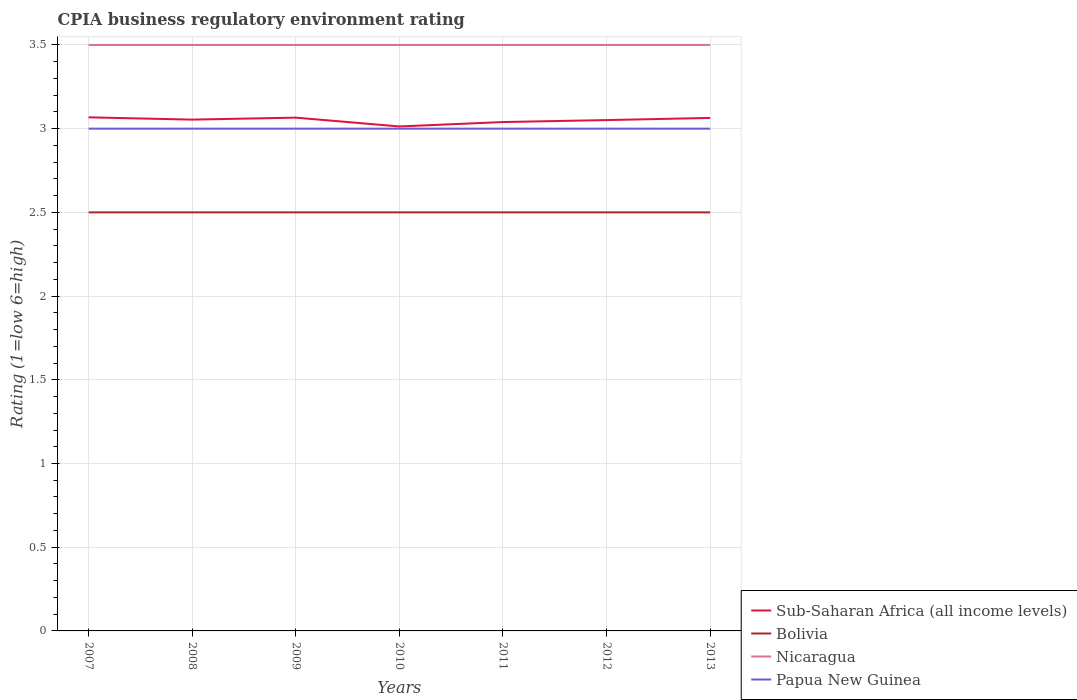Is the number of lines equal to the number of legend labels?
Keep it short and to the point. Yes. Across all years, what is the maximum CPIA rating in Sub-Saharan Africa (all income levels)?
Your answer should be compact. 3.01. In which year was the CPIA rating in Papua New Guinea maximum?
Offer a very short reply. 2007. What is the total CPIA rating in Nicaragua in the graph?
Ensure brevity in your answer.  0. Is the CPIA rating in Nicaragua strictly greater than the CPIA rating in Papua New Guinea over the years?
Make the answer very short. No. How many years are there in the graph?
Ensure brevity in your answer.  7. What is the difference between two consecutive major ticks on the Y-axis?
Provide a short and direct response. 0.5. Where does the legend appear in the graph?
Your answer should be very brief. Bottom right. What is the title of the graph?
Provide a short and direct response. CPIA business regulatory environment rating. Does "Mozambique" appear as one of the legend labels in the graph?
Your response must be concise. No. What is the label or title of the Y-axis?
Offer a terse response. Rating (1=low 6=high). What is the Rating (1=low 6=high) of Sub-Saharan Africa (all income levels) in 2007?
Provide a succinct answer. 3.07. What is the Rating (1=low 6=high) in Bolivia in 2007?
Provide a succinct answer. 2.5. What is the Rating (1=low 6=high) of Nicaragua in 2007?
Your response must be concise. 3.5. What is the Rating (1=low 6=high) in Sub-Saharan Africa (all income levels) in 2008?
Keep it short and to the point. 3.05. What is the Rating (1=low 6=high) of Nicaragua in 2008?
Provide a succinct answer. 3.5. What is the Rating (1=low 6=high) in Sub-Saharan Africa (all income levels) in 2009?
Provide a succinct answer. 3.07. What is the Rating (1=low 6=high) of Sub-Saharan Africa (all income levels) in 2010?
Provide a short and direct response. 3.01. What is the Rating (1=low 6=high) in Bolivia in 2010?
Offer a terse response. 2.5. What is the Rating (1=low 6=high) of Sub-Saharan Africa (all income levels) in 2011?
Your answer should be compact. 3.04. What is the Rating (1=low 6=high) of Sub-Saharan Africa (all income levels) in 2012?
Make the answer very short. 3.05. What is the Rating (1=low 6=high) of Bolivia in 2012?
Your answer should be very brief. 2.5. What is the Rating (1=low 6=high) in Sub-Saharan Africa (all income levels) in 2013?
Offer a very short reply. 3.06. What is the Rating (1=low 6=high) in Nicaragua in 2013?
Provide a short and direct response. 3.5. Across all years, what is the maximum Rating (1=low 6=high) of Sub-Saharan Africa (all income levels)?
Offer a terse response. 3.07. Across all years, what is the maximum Rating (1=low 6=high) in Bolivia?
Give a very brief answer. 2.5. Across all years, what is the maximum Rating (1=low 6=high) in Nicaragua?
Your answer should be very brief. 3.5. Across all years, what is the maximum Rating (1=low 6=high) of Papua New Guinea?
Provide a succinct answer. 3. Across all years, what is the minimum Rating (1=low 6=high) of Sub-Saharan Africa (all income levels)?
Ensure brevity in your answer.  3.01. Across all years, what is the minimum Rating (1=low 6=high) in Nicaragua?
Provide a short and direct response. 3.5. What is the total Rating (1=low 6=high) in Sub-Saharan Africa (all income levels) in the graph?
Your response must be concise. 21.36. What is the difference between the Rating (1=low 6=high) in Sub-Saharan Africa (all income levels) in 2007 and that in 2008?
Make the answer very short. 0.01. What is the difference between the Rating (1=low 6=high) of Papua New Guinea in 2007 and that in 2008?
Provide a succinct answer. 0. What is the difference between the Rating (1=low 6=high) in Sub-Saharan Africa (all income levels) in 2007 and that in 2009?
Offer a very short reply. 0. What is the difference between the Rating (1=low 6=high) of Nicaragua in 2007 and that in 2009?
Your answer should be very brief. 0. What is the difference between the Rating (1=low 6=high) in Sub-Saharan Africa (all income levels) in 2007 and that in 2010?
Make the answer very short. 0.05. What is the difference between the Rating (1=low 6=high) in Sub-Saharan Africa (all income levels) in 2007 and that in 2011?
Offer a very short reply. 0.03. What is the difference between the Rating (1=low 6=high) of Bolivia in 2007 and that in 2011?
Give a very brief answer. 0. What is the difference between the Rating (1=low 6=high) of Sub-Saharan Africa (all income levels) in 2007 and that in 2012?
Give a very brief answer. 0.02. What is the difference between the Rating (1=low 6=high) in Papua New Guinea in 2007 and that in 2012?
Offer a terse response. 0. What is the difference between the Rating (1=low 6=high) of Sub-Saharan Africa (all income levels) in 2007 and that in 2013?
Provide a succinct answer. 0. What is the difference between the Rating (1=low 6=high) in Bolivia in 2007 and that in 2013?
Your response must be concise. 0. What is the difference between the Rating (1=low 6=high) of Papua New Guinea in 2007 and that in 2013?
Keep it short and to the point. 0. What is the difference between the Rating (1=low 6=high) of Sub-Saharan Africa (all income levels) in 2008 and that in 2009?
Provide a succinct answer. -0.01. What is the difference between the Rating (1=low 6=high) of Papua New Guinea in 2008 and that in 2009?
Make the answer very short. 0. What is the difference between the Rating (1=low 6=high) in Sub-Saharan Africa (all income levels) in 2008 and that in 2010?
Your response must be concise. 0.04. What is the difference between the Rating (1=low 6=high) in Nicaragua in 2008 and that in 2010?
Your response must be concise. 0. What is the difference between the Rating (1=low 6=high) of Papua New Guinea in 2008 and that in 2010?
Provide a short and direct response. 0. What is the difference between the Rating (1=low 6=high) of Sub-Saharan Africa (all income levels) in 2008 and that in 2011?
Offer a very short reply. 0.01. What is the difference between the Rating (1=low 6=high) in Nicaragua in 2008 and that in 2011?
Offer a very short reply. 0. What is the difference between the Rating (1=low 6=high) of Papua New Guinea in 2008 and that in 2011?
Ensure brevity in your answer.  0. What is the difference between the Rating (1=low 6=high) of Sub-Saharan Africa (all income levels) in 2008 and that in 2012?
Your answer should be very brief. 0. What is the difference between the Rating (1=low 6=high) of Papua New Guinea in 2008 and that in 2012?
Your answer should be very brief. 0. What is the difference between the Rating (1=low 6=high) in Sub-Saharan Africa (all income levels) in 2008 and that in 2013?
Provide a short and direct response. -0.01. What is the difference between the Rating (1=low 6=high) of Nicaragua in 2008 and that in 2013?
Provide a succinct answer. 0. What is the difference between the Rating (1=low 6=high) of Sub-Saharan Africa (all income levels) in 2009 and that in 2010?
Offer a very short reply. 0.05. What is the difference between the Rating (1=low 6=high) of Sub-Saharan Africa (all income levels) in 2009 and that in 2011?
Keep it short and to the point. 0.03. What is the difference between the Rating (1=low 6=high) in Bolivia in 2009 and that in 2011?
Offer a very short reply. 0. What is the difference between the Rating (1=low 6=high) in Nicaragua in 2009 and that in 2011?
Make the answer very short. 0. What is the difference between the Rating (1=low 6=high) in Papua New Guinea in 2009 and that in 2011?
Ensure brevity in your answer.  0. What is the difference between the Rating (1=low 6=high) of Sub-Saharan Africa (all income levels) in 2009 and that in 2012?
Keep it short and to the point. 0.01. What is the difference between the Rating (1=low 6=high) of Bolivia in 2009 and that in 2012?
Your answer should be compact. 0. What is the difference between the Rating (1=low 6=high) of Papua New Guinea in 2009 and that in 2012?
Make the answer very short. 0. What is the difference between the Rating (1=low 6=high) of Sub-Saharan Africa (all income levels) in 2009 and that in 2013?
Provide a succinct answer. 0. What is the difference between the Rating (1=low 6=high) of Bolivia in 2009 and that in 2013?
Your answer should be compact. 0. What is the difference between the Rating (1=low 6=high) of Nicaragua in 2009 and that in 2013?
Make the answer very short. 0. What is the difference between the Rating (1=low 6=high) in Sub-Saharan Africa (all income levels) in 2010 and that in 2011?
Keep it short and to the point. -0.03. What is the difference between the Rating (1=low 6=high) of Bolivia in 2010 and that in 2011?
Your answer should be very brief. 0. What is the difference between the Rating (1=low 6=high) of Sub-Saharan Africa (all income levels) in 2010 and that in 2012?
Keep it short and to the point. -0.04. What is the difference between the Rating (1=low 6=high) of Bolivia in 2010 and that in 2012?
Make the answer very short. 0. What is the difference between the Rating (1=low 6=high) in Sub-Saharan Africa (all income levels) in 2010 and that in 2013?
Offer a very short reply. -0.05. What is the difference between the Rating (1=low 6=high) of Bolivia in 2010 and that in 2013?
Offer a terse response. 0. What is the difference between the Rating (1=low 6=high) in Nicaragua in 2010 and that in 2013?
Offer a terse response. 0. What is the difference between the Rating (1=low 6=high) of Sub-Saharan Africa (all income levels) in 2011 and that in 2012?
Your answer should be very brief. -0.01. What is the difference between the Rating (1=low 6=high) in Bolivia in 2011 and that in 2012?
Ensure brevity in your answer.  0. What is the difference between the Rating (1=low 6=high) of Papua New Guinea in 2011 and that in 2012?
Your answer should be very brief. 0. What is the difference between the Rating (1=low 6=high) of Sub-Saharan Africa (all income levels) in 2011 and that in 2013?
Give a very brief answer. -0.02. What is the difference between the Rating (1=low 6=high) of Bolivia in 2011 and that in 2013?
Keep it short and to the point. 0. What is the difference between the Rating (1=low 6=high) in Sub-Saharan Africa (all income levels) in 2012 and that in 2013?
Your answer should be very brief. -0.01. What is the difference between the Rating (1=low 6=high) in Bolivia in 2012 and that in 2013?
Offer a terse response. 0. What is the difference between the Rating (1=low 6=high) in Sub-Saharan Africa (all income levels) in 2007 and the Rating (1=low 6=high) in Bolivia in 2008?
Your response must be concise. 0.57. What is the difference between the Rating (1=low 6=high) in Sub-Saharan Africa (all income levels) in 2007 and the Rating (1=low 6=high) in Nicaragua in 2008?
Provide a short and direct response. -0.43. What is the difference between the Rating (1=low 6=high) of Sub-Saharan Africa (all income levels) in 2007 and the Rating (1=low 6=high) of Papua New Guinea in 2008?
Provide a short and direct response. 0.07. What is the difference between the Rating (1=low 6=high) in Sub-Saharan Africa (all income levels) in 2007 and the Rating (1=low 6=high) in Bolivia in 2009?
Keep it short and to the point. 0.57. What is the difference between the Rating (1=low 6=high) in Sub-Saharan Africa (all income levels) in 2007 and the Rating (1=low 6=high) in Nicaragua in 2009?
Your answer should be very brief. -0.43. What is the difference between the Rating (1=low 6=high) in Sub-Saharan Africa (all income levels) in 2007 and the Rating (1=low 6=high) in Papua New Guinea in 2009?
Provide a succinct answer. 0.07. What is the difference between the Rating (1=low 6=high) of Nicaragua in 2007 and the Rating (1=low 6=high) of Papua New Guinea in 2009?
Ensure brevity in your answer.  0.5. What is the difference between the Rating (1=low 6=high) in Sub-Saharan Africa (all income levels) in 2007 and the Rating (1=low 6=high) in Bolivia in 2010?
Your response must be concise. 0.57. What is the difference between the Rating (1=low 6=high) in Sub-Saharan Africa (all income levels) in 2007 and the Rating (1=low 6=high) in Nicaragua in 2010?
Keep it short and to the point. -0.43. What is the difference between the Rating (1=low 6=high) of Sub-Saharan Africa (all income levels) in 2007 and the Rating (1=low 6=high) of Papua New Guinea in 2010?
Ensure brevity in your answer.  0.07. What is the difference between the Rating (1=low 6=high) of Bolivia in 2007 and the Rating (1=low 6=high) of Nicaragua in 2010?
Keep it short and to the point. -1. What is the difference between the Rating (1=low 6=high) of Bolivia in 2007 and the Rating (1=low 6=high) of Papua New Guinea in 2010?
Provide a succinct answer. -0.5. What is the difference between the Rating (1=low 6=high) in Sub-Saharan Africa (all income levels) in 2007 and the Rating (1=low 6=high) in Bolivia in 2011?
Offer a terse response. 0.57. What is the difference between the Rating (1=low 6=high) of Sub-Saharan Africa (all income levels) in 2007 and the Rating (1=low 6=high) of Nicaragua in 2011?
Keep it short and to the point. -0.43. What is the difference between the Rating (1=low 6=high) of Sub-Saharan Africa (all income levels) in 2007 and the Rating (1=low 6=high) of Papua New Guinea in 2011?
Provide a short and direct response. 0.07. What is the difference between the Rating (1=low 6=high) in Bolivia in 2007 and the Rating (1=low 6=high) in Nicaragua in 2011?
Provide a succinct answer. -1. What is the difference between the Rating (1=low 6=high) in Nicaragua in 2007 and the Rating (1=low 6=high) in Papua New Guinea in 2011?
Keep it short and to the point. 0.5. What is the difference between the Rating (1=low 6=high) of Sub-Saharan Africa (all income levels) in 2007 and the Rating (1=low 6=high) of Bolivia in 2012?
Make the answer very short. 0.57. What is the difference between the Rating (1=low 6=high) in Sub-Saharan Africa (all income levels) in 2007 and the Rating (1=low 6=high) in Nicaragua in 2012?
Keep it short and to the point. -0.43. What is the difference between the Rating (1=low 6=high) of Sub-Saharan Africa (all income levels) in 2007 and the Rating (1=low 6=high) of Papua New Guinea in 2012?
Provide a short and direct response. 0.07. What is the difference between the Rating (1=low 6=high) in Bolivia in 2007 and the Rating (1=low 6=high) in Papua New Guinea in 2012?
Give a very brief answer. -0.5. What is the difference between the Rating (1=low 6=high) in Nicaragua in 2007 and the Rating (1=low 6=high) in Papua New Guinea in 2012?
Provide a short and direct response. 0.5. What is the difference between the Rating (1=low 6=high) of Sub-Saharan Africa (all income levels) in 2007 and the Rating (1=low 6=high) of Bolivia in 2013?
Your response must be concise. 0.57. What is the difference between the Rating (1=low 6=high) of Sub-Saharan Africa (all income levels) in 2007 and the Rating (1=low 6=high) of Nicaragua in 2013?
Provide a short and direct response. -0.43. What is the difference between the Rating (1=low 6=high) of Sub-Saharan Africa (all income levels) in 2007 and the Rating (1=low 6=high) of Papua New Guinea in 2013?
Give a very brief answer. 0.07. What is the difference between the Rating (1=low 6=high) in Bolivia in 2007 and the Rating (1=low 6=high) in Nicaragua in 2013?
Your answer should be very brief. -1. What is the difference between the Rating (1=low 6=high) in Bolivia in 2007 and the Rating (1=low 6=high) in Papua New Guinea in 2013?
Provide a succinct answer. -0.5. What is the difference between the Rating (1=low 6=high) of Sub-Saharan Africa (all income levels) in 2008 and the Rating (1=low 6=high) of Bolivia in 2009?
Your answer should be compact. 0.55. What is the difference between the Rating (1=low 6=high) in Sub-Saharan Africa (all income levels) in 2008 and the Rating (1=low 6=high) in Nicaragua in 2009?
Ensure brevity in your answer.  -0.45. What is the difference between the Rating (1=low 6=high) of Sub-Saharan Africa (all income levels) in 2008 and the Rating (1=low 6=high) of Papua New Guinea in 2009?
Provide a succinct answer. 0.05. What is the difference between the Rating (1=low 6=high) of Sub-Saharan Africa (all income levels) in 2008 and the Rating (1=low 6=high) of Bolivia in 2010?
Your answer should be very brief. 0.55. What is the difference between the Rating (1=low 6=high) of Sub-Saharan Africa (all income levels) in 2008 and the Rating (1=low 6=high) of Nicaragua in 2010?
Offer a terse response. -0.45. What is the difference between the Rating (1=low 6=high) in Sub-Saharan Africa (all income levels) in 2008 and the Rating (1=low 6=high) in Papua New Guinea in 2010?
Give a very brief answer. 0.05. What is the difference between the Rating (1=low 6=high) of Bolivia in 2008 and the Rating (1=low 6=high) of Nicaragua in 2010?
Offer a very short reply. -1. What is the difference between the Rating (1=low 6=high) in Bolivia in 2008 and the Rating (1=low 6=high) in Papua New Guinea in 2010?
Your response must be concise. -0.5. What is the difference between the Rating (1=low 6=high) in Sub-Saharan Africa (all income levels) in 2008 and the Rating (1=low 6=high) in Bolivia in 2011?
Your response must be concise. 0.55. What is the difference between the Rating (1=low 6=high) in Sub-Saharan Africa (all income levels) in 2008 and the Rating (1=low 6=high) in Nicaragua in 2011?
Offer a very short reply. -0.45. What is the difference between the Rating (1=low 6=high) of Sub-Saharan Africa (all income levels) in 2008 and the Rating (1=low 6=high) of Papua New Guinea in 2011?
Your answer should be compact. 0.05. What is the difference between the Rating (1=low 6=high) in Bolivia in 2008 and the Rating (1=low 6=high) in Nicaragua in 2011?
Give a very brief answer. -1. What is the difference between the Rating (1=low 6=high) in Sub-Saharan Africa (all income levels) in 2008 and the Rating (1=low 6=high) in Bolivia in 2012?
Offer a very short reply. 0.55. What is the difference between the Rating (1=low 6=high) in Sub-Saharan Africa (all income levels) in 2008 and the Rating (1=low 6=high) in Nicaragua in 2012?
Your answer should be compact. -0.45. What is the difference between the Rating (1=low 6=high) of Sub-Saharan Africa (all income levels) in 2008 and the Rating (1=low 6=high) of Papua New Guinea in 2012?
Ensure brevity in your answer.  0.05. What is the difference between the Rating (1=low 6=high) in Nicaragua in 2008 and the Rating (1=low 6=high) in Papua New Guinea in 2012?
Keep it short and to the point. 0.5. What is the difference between the Rating (1=low 6=high) of Sub-Saharan Africa (all income levels) in 2008 and the Rating (1=low 6=high) of Bolivia in 2013?
Provide a succinct answer. 0.55. What is the difference between the Rating (1=low 6=high) in Sub-Saharan Africa (all income levels) in 2008 and the Rating (1=low 6=high) in Nicaragua in 2013?
Provide a short and direct response. -0.45. What is the difference between the Rating (1=low 6=high) in Sub-Saharan Africa (all income levels) in 2008 and the Rating (1=low 6=high) in Papua New Guinea in 2013?
Your response must be concise. 0.05. What is the difference between the Rating (1=low 6=high) in Nicaragua in 2008 and the Rating (1=low 6=high) in Papua New Guinea in 2013?
Provide a succinct answer. 0.5. What is the difference between the Rating (1=low 6=high) of Sub-Saharan Africa (all income levels) in 2009 and the Rating (1=low 6=high) of Bolivia in 2010?
Ensure brevity in your answer.  0.57. What is the difference between the Rating (1=low 6=high) in Sub-Saharan Africa (all income levels) in 2009 and the Rating (1=low 6=high) in Nicaragua in 2010?
Offer a very short reply. -0.43. What is the difference between the Rating (1=low 6=high) in Sub-Saharan Africa (all income levels) in 2009 and the Rating (1=low 6=high) in Papua New Guinea in 2010?
Your answer should be very brief. 0.07. What is the difference between the Rating (1=low 6=high) of Bolivia in 2009 and the Rating (1=low 6=high) of Nicaragua in 2010?
Ensure brevity in your answer.  -1. What is the difference between the Rating (1=low 6=high) in Bolivia in 2009 and the Rating (1=low 6=high) in Papua New Guinea in 2010?
Make the answer very short. -0.5. What is the difference between the Rating (1=low 6=high) of Sub-Saharan Africa (all income levels) in 2009 and the Rating (1=low 6=high) of Bolivia in 2011?
Keep it short and to the point. 0.57. What is the difference between the Rating (1=low 6=high) of Sub-Saharan Africa (all income levels) in 2009 and the Rating (1=low 6=high) of Nicaragua in 2011?
Provide a succinct answer. -0.43. What is the difference between the Rating (1=low 6=high) of Sub-Saharan Africa (all income levels) in 2009 and the Rating (1=low 6=high) of Papua New Guinea in 2011?
Provide a succinct answer. 0.07. What is the difference between the Rating (1=low 6=high) of Bolivia in 2009 and the Rating (1=low 6=high) of Nicaragua in 2011?
Your response must be concise. -1. What is the difference between the Rating (1=low 6=high) in Nicaragua in 2009 and the Rating (1=low 6=high) in Papua New Guinea in 2011?
Your answer should be compact. 0.5. What is the difference between the Rating (1=low 6=high) of Sub-Saharan Africa (all income levels) in 2009 and the Rating (1=low 6=high) of Bolivia in 2012?
Provide a short and direct response. 0.57. What is the difference between the Rating (1=low 6=high) in Sub-Saharan Africa (all income levels) in 2009 and the Rating (1=low 6=high) in Nicaragua in 2012?
Your response must be concise. -0.43. What is the difference between the Rating (1=low 6=high) of Sub-Saharan Africa (all income levels) in 2009 and the Rating (1=low 6=high) of Papua New Guinea in 2012?
Provide a succinct answer. 0.07. What is the difference between the Rating (1=low 6=high) of Sub-Saharan Africa (all income levels) in 2009 and the Rating (1=low 6=high) of Bolivia in 2013?
Your response must be concise. 0.57. What is the difference between the Rating (1=low 6=high) of Sub-Saharan Africa (all income levels) in 2009 and the Rating (1=low 6=high) of Nicaragua in 2013?
Provide a short and direct response. -0.43. What is the difference between the Rating (1=low 6=high) of Sub-Saharan Africa (all income levels) in 2009 and the Rating (1=low 6=high) of Papua New Guinea in 2013?
Your response must be concise. 0.07. What is the difference between the Rating (1=low 6=high) of Bolivia in 2009 and the Rating (1=low 6=high) of Papua New Guinea in 2013?
Keep it short and to the point. -0.5. What is the difference between the Rating (1=low 6=high) in Nicaragua in 2009 and the Rating (1=low 6=high) in Papua New Guinea in 2013?
Give a very brief answer. 0.5. What is the difference between the Rating (1=low 6=high) of Sub-Saharan Africa (all income levels) in 2010 and the Rating (1=low 6=high) of Bolivia in 2011?
Your response must be concise. 0.51. What is the difference between the Rating (1=low 6=high) in Sub-Saharan Africa (all income levels) in 2010 and the Rating (1=low 6=high) in Nicaragua in 2011?
Offer a very short reply. -0.49. What is the difference between the Rating (1=low 6=high) in Sub-Saharan Africa (all income levels) in 2010 and the Rating (1=low 6=high) in Papua New Guinea in 2011?
Provide a short and direct response. 0.01. What is the difference between the Rating (1=low 6=high) in Bolivia in 2010 and the Rating (1=low 6=high) in Nicaragua in 2011?
Keep it short and to the point. -1. What is the difference between the Rating (1=low 6=high) of Sub-Saharan Africa (all income levels) in 2010 and the Rating (1=low 6=high) of Bolivia in 2012?
Keep it short and to the point. 0.51. What is the difference between the Rating (1=low 6=high) in Sub-Saharan Africa (all income levels) in 2010 and the Rating (1=low 6=high) in Nicaragua in 2012?
Offer a terse response. -0.49. What is the difference between the Rating (1=low 6=high) of Sub-Saharan Africa (all income levels) in 2010 and the Rating (1=low 6=high) of Papua New Guinea in 2012?
Provide a succinct answer. 0.01. What is the difference between the Rating (1=low 6=high) in Bolivia in 2010 and the Rating (1=low 6=high) in Nicaragua in 2012?
Make the answer very short. -1. What is the difference between the Rating (1=low 6=high) of Nicaragua in 2010 and the Rating (1=low 6=high) of Papua New Guinea in 2012?
Provide a short and direct response. 0.5. What is the difference between the Rating (1=low 6=high) in Sub-Saharan Africa (all income levels) in 2010 and the Rating (1=low 6=high) in Bolivia in 2013?
Provide a succinct answer. 0.51. What is the difference between the Rating (1=low 6=high) in Sub-Saharan Africa (all income levels) in 2010 and the Rating (1=low 6=high) in Nicaragua in 2013?
Offer a terse response. -0.49. What is the difference between the Rating (1=low 6=high) of Sub-Saharan Africa (all income levels) in 2010 and the Rating (1=low 6=high) of Papua New Guinea in 2013?
Provide a succinct answer. 0.01. What is the difference between the Rating (1=low 6=high) of Bolivia in 2010 and the Rating (1=low 6=high) of Papua New Guinea in 2013?
Provide a succinct answer. -0.5. What is the difference between the Rating (1=low 6=high) of Nicaragua in 2010 and the Rating (1=low 6=high) of Papua New Guinea in 2013?
Your response must be concise. 0.5. What is the difference between the Rating (1=low 6=high) in Sub-Saharan Africa (all income levels) in 2011 and the Rating (1=low 6=high) in Bolivia in 2012?
Make the answer very short. 0.54. What is the difference between the Rating (1=low 6=high) in Sub-Saharan Africa (all income levels) in 2011 and the Rating (1=low 6=high) in Nicaragua in 2012?
Give a very brief answer. -0.46. What is the difference between the Rating (1=low 6=high) of Sub-Saharan Africa (all income levels) in 2011 and the Rating (1=low 6=high) of Papua New Guinea in 2012?
Offer a very short reply. 0.04. What is the difference between the Rating (1=low 6=high) of Bolivia in 2011 and the Rating (1=low 6=high) of Nicaragua in 2012?
Provide a short and direct response. -1. What is the difference between the Rating (1=low 6=high) of Sub-Saharan Africa (all income levels) in 2011 and the Rating (1=low 6=high) of Bolivia in 2013?
Provide a succinct answer. 0.54. What is the difference between the Rating (1=low 6=high) of Sub-Saharan Africa (all income levels) in 2011 and the Rating (1=low 6=high) of Nicaragua in 2013?
Your response must be concise. -0.46. What is the difference between the Rating (1=low 6=high) of Sub-Saharan Africa (all income levels) in 2011 and the Rating (1=low 6=high) of Papua New Guinea in 2013?
Provide a succinct answer. 0.04. What is the difference between the Rating (1=low 6=high) in Bolivia in 2011 and the Rating (1=low 6=high) in Nicaragua in 2013?
Provide a succinct answer. -1. What is the difference between the Rating (1=low 6=high) of Nicaragua in 2011 and the Rating (1=low 6=high) of Papua New Guinea in 2013?
Your answer should be very brief. 0.5. What is the difference between the Rating (1=low 6=high) in Sub-Saharan Africa (all income levels) in 2012 and the Rating (1=low 6=high) in Bolivia in 2013?
Keep it short and to the point. 0.55. What is the difference between the Rating (1=low 6=high) of Sub-Saharan Africa (all income levels) in 2012 and the Rating (1=low 6=high) of Nicaragua in 2013?
Provide a succinct answer. -0.45. What is the difference between the Rating (1=low 6=high) of Sub-Saharan Africa (all income levels) in 2012 and the Rating (1=low 6=high) of Papua New Guinea in 2013?
Provide a succinct answer. 0.05. What is the difference between the Rating (1=low 6=high) in Nicaragua in 2012 and the Rating (1=low 6=high) in Papua New Guinea in 2013?
Keep it short and to the point. 0.5. What is the average Rating (1=low 6=high) of Sub-Saharan Africa (all income levels) per year?
Your answer should be compact. 3.05. What is the average Rating (1=low 6=high) in Bolivia per year?
Provide a short and direct response. 2.5. In the year 2007, what is the difference between the Rating (1=low 6=high) of Sub-Saharan Africa (all income levels) and Rating (1=low 6=high) of Bolivia?
Your answer should be very brief. 0.57. In the year 2007, what is the difference between the Rating (1=low 6=high) of Sub-Saharan Africa (all income levels) and Rating (1=low 6=high) of Nicaragua?
Offer a very short reply. -0.43. In the year 2007, what is the difference between the Rating (1=low 6=high) of Sub-Saharan Africa (all income levels) and Rating (1=low 6=high) of Papua New Guinea?
Make the answer very short. 0.07. In the year 2007, what is the difference between the Rating (1=low 6=high) of Bolivia and Rating (1=low 6=high) of Nicaragua?
Provide a short and direct response. -1. In the year 2008, what is the difference between the Rating (1=low 6=high) of Sub-Saharan Africa (all income levels) and Rating (1=low 6=high) of Bolivia?
Your answer should be compact. 0.55. In the year 2008, what is the difference between the Rating (1=low 6=high) of Sub-Saharan Africa (all income levels) and Rating (1=low 6=high) of Nicaragua?
Provide a short and direct response. -0.45. In the year 2008, what is the difference between the Rating (1=low 6=high) of Sub-Saharan Africa (all income levels) and Rating (1=low 6=high) of Papua New Guinea?
Provide a succinct answer. 0.05. In the year 2008, what is the difference between the Rating (1=low 6=high) of Bolivia and Rating (1=low 6=high) of Nicaragua?
Your response must be concise. -1. In the year 2009, what is the difference between the Rating (1=low 6=high) of Sub-Saharan Africa (all income levels) and Rating (1=low 6=high) of Bolivia?
Provide a short and direct response. 0.57. In the year 2009, what is the difference between the Rating (1=low 6=high) in Sub-Saharan Africa (all income levels) and Rating (1=low 6=high) in Nicaragua?
Make the answer very short. -0.43. In the year 2009, what is the difference between the Rating (1=low 6=high) of Sub-Saharan Africa (all income levels) and Rating (1=low 6=high) of Papua New Guinea?
Give a very brief answer. 0.07. In the year 2009, what is the difference between the Rating (1=low 6=high) of Bolivia and Rating (1=low 6=high) of Nicaragua?
Give a very brief answer. -1. In the year 2009, what is the difference between the Rating (1=low 6=high) in Bolivia and Rating (1=low 6=high) in Papua New Guinea?
Your response must be concise. -0.5. In the year 2009, what is the difference between the Rating (1=low 6=high) of Nicaragua and Rating (1=low 6=high) of Papua New Guinea?
Your response must be concise. 0.5. In the year 2010, what is the difference between the Rating (1=low 6=high) of Sub-Saharan Africa (all income levels) and Rating (1=low 6=high) of Bolivia?
Offer a very short reply. 0.51. In the year 2010, what is the difference between the Rating (1=low 6=high) of Sub-Saharan Africa (all income levels) and Rating (1=low 6=high) of Nicaragua?
Offer a very short reply. -0.49. In the year 2010, what is the difference between the Rating (1=low 6=high) in Sub-Saharan Africa (all income levels) and Rating (1=low 6=high) in Papua New Guinea?
Provide a succinct answer. 0.01. In the year 2010, what is the difference between the Rating (1=low 6=high) in Bolivia and Rating (1=low 6=high) in Nicaragua?
Make the answer very short. -1. In the year 2011, what is the difference between the Rating (1=low 6=high) of Sub-Saharan Africa (all income levels) and Rating (1=low 6=high) of Bolivia?
Offer a terse response. 0.54. In the year 2011, what is the difference between the Rating (1=low 6=high) in Sub-Saharan Africa (all income levels) and Rating (1=low 6=high) in Nicaragua?
Make the answer very short. -0.46. In the year 2011, what is the difference between the Rating (1=low 6=high) in Sub-Saharan Africa (all income levels) and Rating (1=low 6=high) in Papua New Guinea?
Your answer should be compact. 0.04. In the year 2012, what is the difference between the Rating (1=low 6=high) in Sub-Saharan Africa (all income levels) and Rating (1=low 6=high) in Bolivia?
Your response must be concise. 0.55. In the year 2012, what is the difference between the Rating (1=low 6=high) of Sub-Saharan Africa (all income levels) and Rating (1=low 6=high) of Nicaragua?
Give a very brief answer. -0.45. In the year 2012, what is the difference between the Rating (1=low 6=high) in Sub-Saharan Africa (all income levels) and Rating (1=low 6=high) in Papua New Guinea?
Offer a terse response. 0.05. In the year 2012, what is the difference between the Rating (1=low 6=high) of Bolivia and Rating (1=low 6=high) of Nicaragua?
Your answer should be compact. -1. In the year 2012, what is the difference between the Rating (1=low 6=high) of Bolivia and Rating (1=low 6=high) of Papua New Guinea?
Keep it short and to the point. -0.5. In the year 2013, what is the difference between the Rating (1=low 6=high) in Sub-Saharan Africa (all income levels) and Rating (1=low 6=high) in Bolivia?
Keep it short and to the point. 0.56. In the year 2013, what is the difference between the Rating (1=low 6=high) of Sub-Saharan Africa (all income levels) and Rating (1=low 6=high) of Nicaragua?
Provide a succinct answer. -0.44. In the year 2013, what is the difference between the Rating (1=low 6=high) in Sub-Saharan Africa (all income levels) and Rating (1=low 6=high) in Papua New Guinea?
Your answer should be compact. 0.06. In the year 2013, what is the difference between the Rating (1=low 6=high) in Bolivia and Rating (1=low 6=high) in Nicaragua?
Your answer should be very brief. -1. What is the ratio of the Rating (1=low 6=high) in Nicaragua in 2007 to that in 2008?
Your answer should be very brief. 1. What is the ratio of the Rating (1=low 6=high) of Papua New Guinea in 2007 to that in 2008?
Keep it short and to the point. 1. What is the ratio of the Rating (1=low 6=high) of Sub-Saharan Africa (all income levels) in 2007 to that in 2009?
Keep it short and to the point. 1. What is the ratio of the Rating (1=low 6=high) of Nicaragua in 2007 to that in 2009?
Provide a succinct answer. 1. What is the ratio of the Rating (1=low 6=high) in Sub-Saharan Africa (all income levels) in 2007 to that in 2010?
Provide a succinct answer. 1.02. What is the ratio of the Rating (1=low 6=high) of Bolivia in 2007 to that in 2010?
Make the answer very short. 1. What is the ratio of the Rating (1=low 6=high) of Nicaragua in 2007 to that in 2010?
Your answer should be compact. 1. What is the ratio of the Rating (1=low 6=high) of Sub-Saharan Africa (all income levels) in 2007 to that in 2011?
Ensure brevity in your answer.  1.01. What is the ratio of the Rating (1=low 6=high) in Bolivia in 2007 to that in 2011?
Ensure brevity in your answer.  1. What is the ratio of the Rating (1=low 6=high) in Papua New Guinea in 2007 to that in 2011?
Give a very brief answer. 1. What is the ratio of the Rating (1=low 6=high) of Sub-Saharan Africa (all income levels) in 2007 to that in 2012?
Ensure brevity in your answer.  1.01. What is the ratio of the Rating (1=low 6=high) of Papua New Guinea in 2007 to that in 2012?
Your answer should be compact. 1. What is the ratio of the Rating (1=low 6=high) of Sub-Saharan Africa (all income levels) in 2007 to that in 2013?
Offer a terse response. 1. What is the ratio of the Rating (1=low 6=high) in Papua New Guinea in 2007 to that in 2013?
Offer a very short reply. 1. What is the ratio of the Rating (1=low 6=high) in Sub-Saharan Africa (all income levels) in 2008 to that in 2009?
Your answer should be very brief. 1. What is the ratio of the Rating (1=low 6=high) in Bolivia in 2008 to that in 2009?
Your answer should be compact. 1. What is the ratio of the Rating (1=low 6=high) in Papua New Guinea in 2008 to that in 2009?
Give a very brief answer. 1. What is the ratio of the Rating (1=low 6=high) of Sub-Saharan Africa (all income levels) in 2008 to that in 2010?
Your answer should be compact. 1.01. What is the ratio of the Rating (1=low 6=high) in Bolivia in 2008 to that in 2011?
Provide a succinct answer. 1. What is the ratio of the Rating (1=low 6=high) of Nicaragua in 2008 to that in 2011?
Your answer should be very brief. 1. What is the ratio of the Rating (1=low 6=high) of Papua New Guinea in 2008 to that in 2011?
Keep it short and to the point. 1. What is the ratio of the Rating (1=low 6=high) of Sub-Saharan Africa (all income levels) in 2008 to that in 2012?
Give a very brief answer. 1. What is the ratio of the Rating (1=low 6=high) in Bolivia in 2008 to that in 2012?
Your response must be concise. 1. What is the ratio of the Rating (1=low 6=high) in Bolivia in 2008 to that in 2013?
Your answer should be very brief. 1. What is the ratio of the Rating (1=low 6=high) of Sub-Saharan Africa (all income levels) in 2009 to that in 2010?
Your answer should be compact. 1.02. What is the ratio of the Rating (1=low 6=high) in Bolivia in 2009 to that in 2010?
Keep it short and to the point. 1. What is the ratio of the Rating (1=low 6=high) of Papua New Guinea in 2009 to that in 2010?
Offer a very short reply. 1. What is the ratio of the Rating (1=low 6=high) of Sub-Saharan Africa (all income levels) in 2009 to that in 2011?
Keep it short and to the point. 1.01. What is the ratio of the Rating (1=low 6=high) in Bolivia in 2009 to that in 2011?
Your answer should be very brief. 1. What is the ratio of the Rating (1=low 6=high) in Papua New Guinea in 2009 to that in 2011?
Give a very brief answer. 1. What is the ratio of the Rating (1=low 6=high) in Nicaragua in 2009 to that in 2012?
Provide a succinct answer. 1. What is the ratio of the Rating (1=low 6=high) of Sub-Saharan Africa (all income levels) in 2009 to that in 2013?
Ensure brevity in your answer.  1. What is the ratio of the Rating (1=low 6=high) of Papua New Guinea in 2009 to that in 2013?
Provide a succinct answer. 1. What is the ratio of the Rating (1=low 6=high) in Bolivia in 2010 to that in 2011?
Make the answer very short. 1. What is the ratio of the Rating (1=low 6=high) in Sub-Saharan Africa (all income levels) in 2010 to that in 2012?
Make the answer very short. 0.99. What is the ratio of the Rating (1=low 6=high) in Bolivia in 2010 to that in 2012?
Make the answer very short. 1. What is the ratio of the Rating (1=low 6=high) in Nicaragua in 2010 to that in 2012?
Give a very brief answer. 1. What is the ratio of the Rating (1=low 6=high) in Sub-Saharan Africa (all income levels) in 2010 to that in 2013?
Your answer should be very brief. 0.98. What is the ratio of the Rating (1=low 6=high) of Bolivia in 2010 to that in 2013?
Make the answer very short. 1. What is the ratio of the Rating (1=low 6=high) of Bolivia in 2011 to that in 2012?
Your answer should be compact. 1. What is the ratio of the Rating (1=low 6=high) in Papua New Guinea in 2011 to that in 2012?
Ensure brevity in your answer.  1. What is the ratio of the Rating (1=low 6=high) of Sub-Saharan Africa (all income levels) in 2011 to that in 2013?
Provide a short and direct response. 0.99. What is the ratio of the Rating (1=low 6=high) of Nicaragua in 2011 to that in 2013?
Provide a short and direct response. 1. What is the ratio of the Rating (1=low 6=high) of Papua New Guinea in 2011 to that in 2013?
Make the answer very short. 1. What is the ratio of the Rating (1=low 6=high) in Papua New Guinea in 2012 to that in 2013?
Your response must be concise. 1. What is the difference between the highest and the second highest Rating (1=low 6=high) of Sub-Saharan Africa (all income levels)?
Provide a short and direct response. 0. What is the difference between the highest and the second highest Rating (1=low 6=high) in Papua New Guinea?
Offer a terse response. 0. What is the difference between the highest and the lowest Rating (1=low 6=high) in Sub-Saharan Africa (all income levels)?
Your response must be concise. 0.05. What is the difference between the highest and the lowest Rating (1=low 6=high) in Nicaragua?
Your answer should be very brief. 0. 